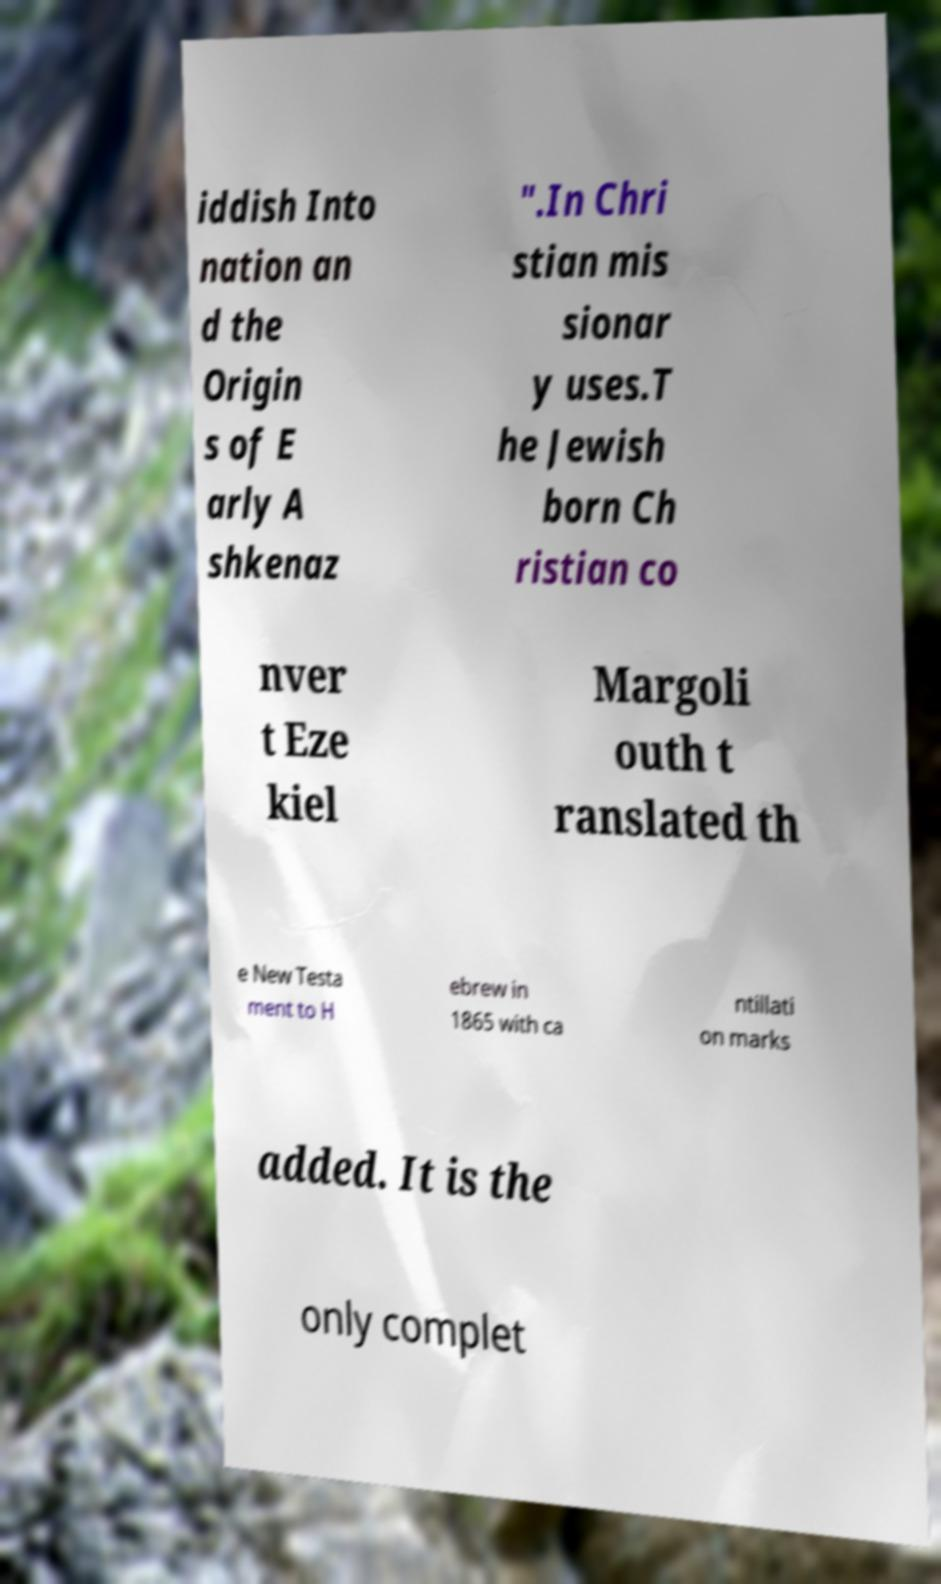Can you read and provide the text displayed in the image?This photo seems to have some interesting text. Can you extract and type it out for me? iddish Into nation an d the Origin s of E arly A shkenaz ".In Chri stian mis sionar y uses.T he Jewish born Ch ristian co nver t Eze kiel Margoli outh t ranslated th e New Testa ment to H ebrew in 1865 with ca ntillati on marks added. It is the only complet 